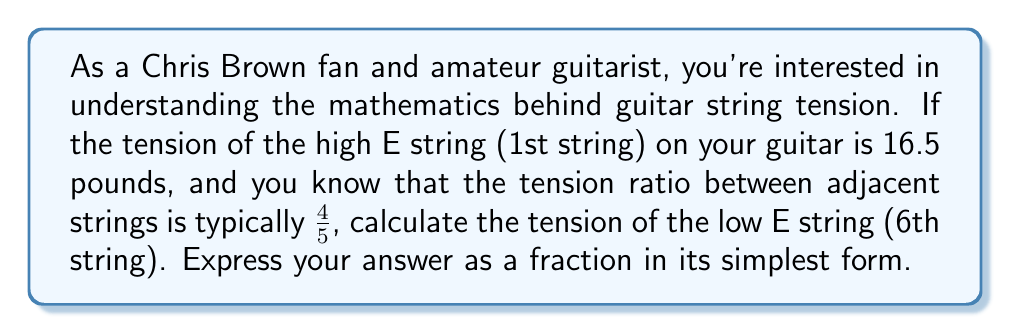Could you help me with this problem? Let's approach this step-by-step:

1) We start with the high E string (1st string) tension of 16.5 pounds.

2) The tension ratio between adjacent strings is $\frac{4}{5}$. This means that each string has $\frac{4}{5}$ of the tension of the string above it.

3) To find the tension of the 6th string, we need to apply this ratio five times (moving from the 1st to the 6th string).

4) Mathematically, this can be expressed as:

   $$T_6 = 16.5 \cdot \left(\frac{4}{5}\right)^5$$

   Where $T_6$ is the tension of the 6th string.

5) Let's calculate this:

   $$T_6 = 16.5 \cdot \frac{4^5}{5^5} = 16.5 \cdot \frac{1024}{3125}$$

6) Multiply the fractions:

   $$T_6 = \frac{16.5 \cdot 1024}{3125} = \frac{16896}{3125}$$

7) This fraction is already in its simplest form, as 16896 and 3125 have no common factors other than 1.

Thus, the tension of the low E string (6th string) is $\frac{16896}{3125}$ pounds.
Answer: $\frac{16896}{3125}$ pounds 